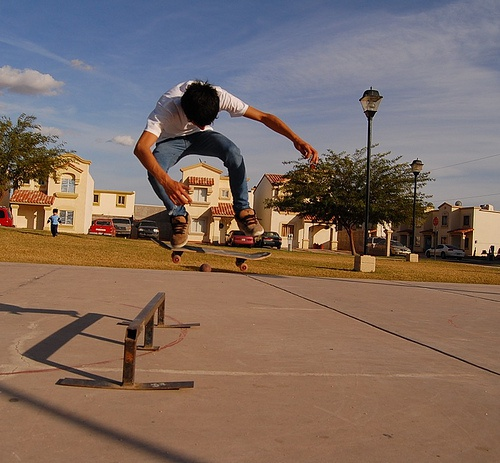Describe the objects in this image and their specific colors. I can see people in gray, black, maroon, and brown tones, skateboard in gray, black, olive, and maroon tones, car in gray and black tones, car in gray, black, and maroon tones, and car in gray, brown, maroon, and black tones in this image. 